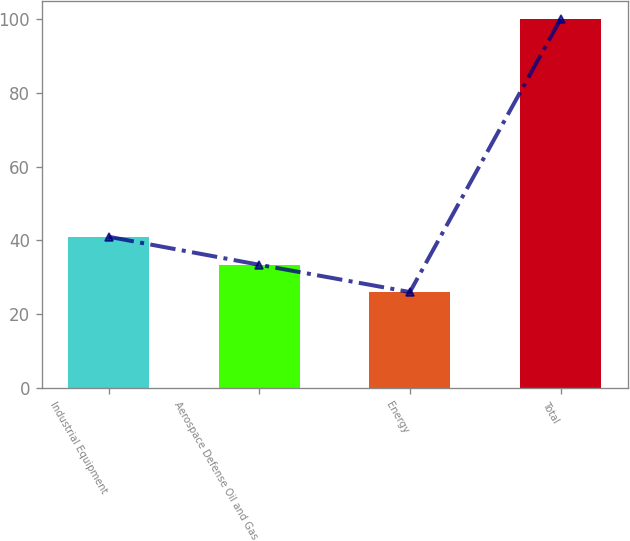Convert chart to OTSL. <chart><loc_0><loc_0><loc_500><loc_500><bar_chart><fcel>Industrial Equipment<fcel>Aerospace Defense Oil and Gas<fcel>Energy<fcel>Total<nl><fcel>41<fcel>33.4<fcel>26<fcel>100<nl></chart> 